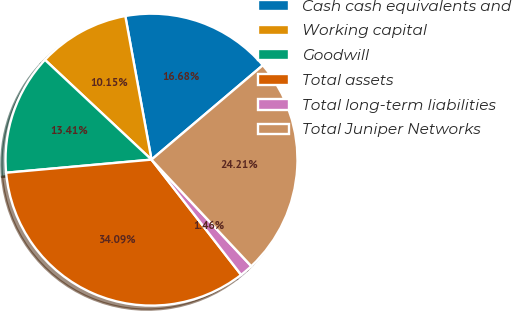<chart> <loc_0><loc_0><loc_500><loc_500><pie_chart><fcel>Cash cash equivalents and<fcel>Working capital<fcel>Goodwill<fcel>Total assets<fcel>Total long-term liabilities<fcel>Total Juniper Networks<nl><fcel>16.68%<fcel>10.15%<fcel>13.41%<fcel>34.09%<fcel>1.46%<fcel>24.21%<nl></chart> 